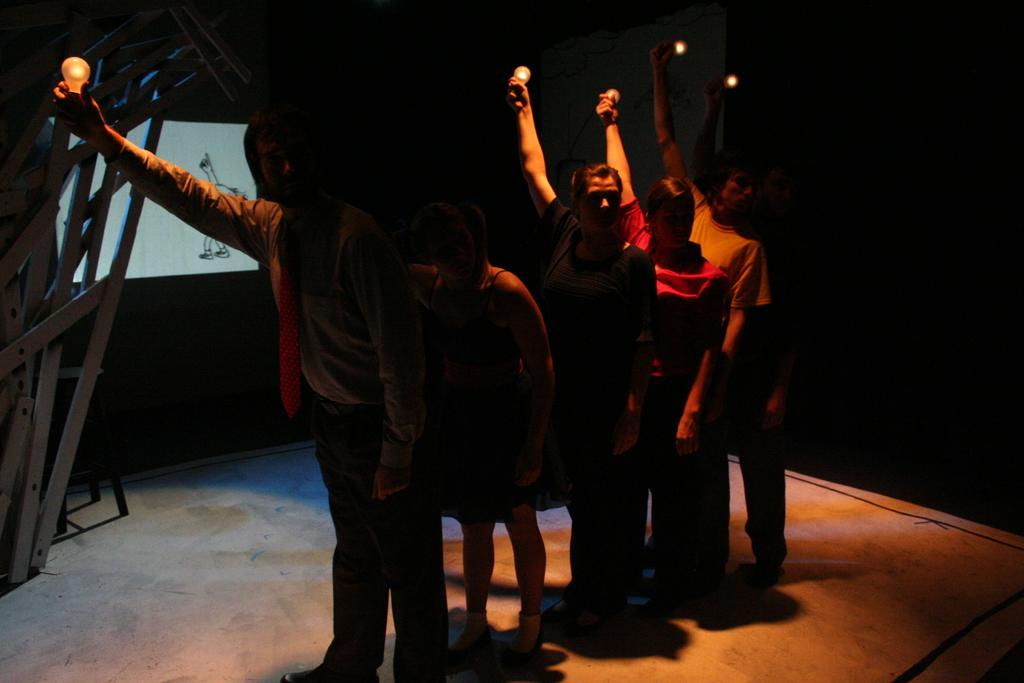What are the people in the image holding? The people in the image are holding bulbs. What other objects can be seen in the image? There are iron rods in the image. What might be used for displaying information or images in the image? There is a screen in the image. What can be observed about the lighting conditions in the image? The background of the image is dark. What type of amusement can be seen in the image? There is no amusement present in the image; it features people holding bulbs, iron rods, and a screen. How does the person in the image breathe while holding the bulb? The image does not show the person breathing, and it is not possible to determine their breathing pattern based on the image alone. 